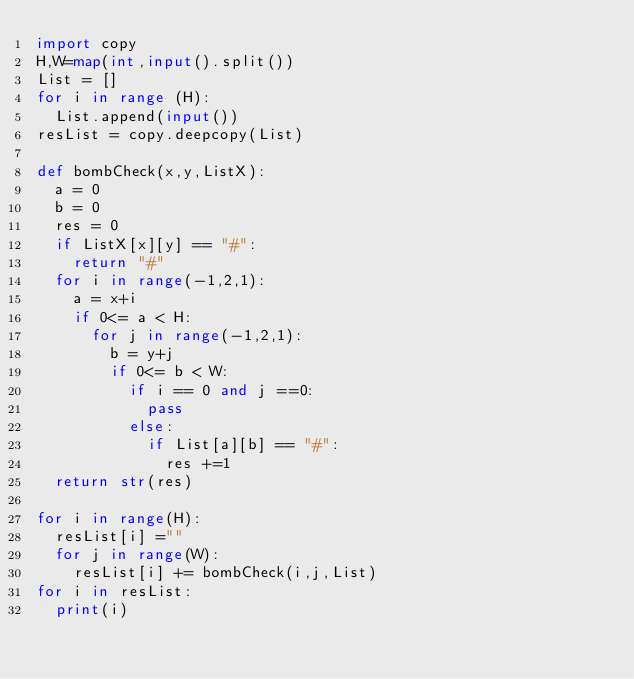<code> <loc_0><loc_0><loc_500><loc_500><_Python_>import copy
H,W=map(int,input().split())
List = []
for i in range (H):
  List.append(input())
resList = copy.deepcopy(List)

def bombCheck(x,y,ListX):  
  a = 0
  b = 0
  res = 0
  if ListX[x][y] == "#":
    return "#"
  for i in range(-1,2,1):
    a = x+i
    if 0<= a < H:
      for j in range(-1,2,1):
        b = y+j
        if 0<= b < W:
          if i == 0 and j ==0:
            pass
          else:
            if List[a][b] == "#":
              res +=1
  return str(res)

for i in range(H):
  resList[i] =""
  for j in range(W):
    resList[i] += bombCheck(i,j,List)
for i in resList:
  print(i)</code> 